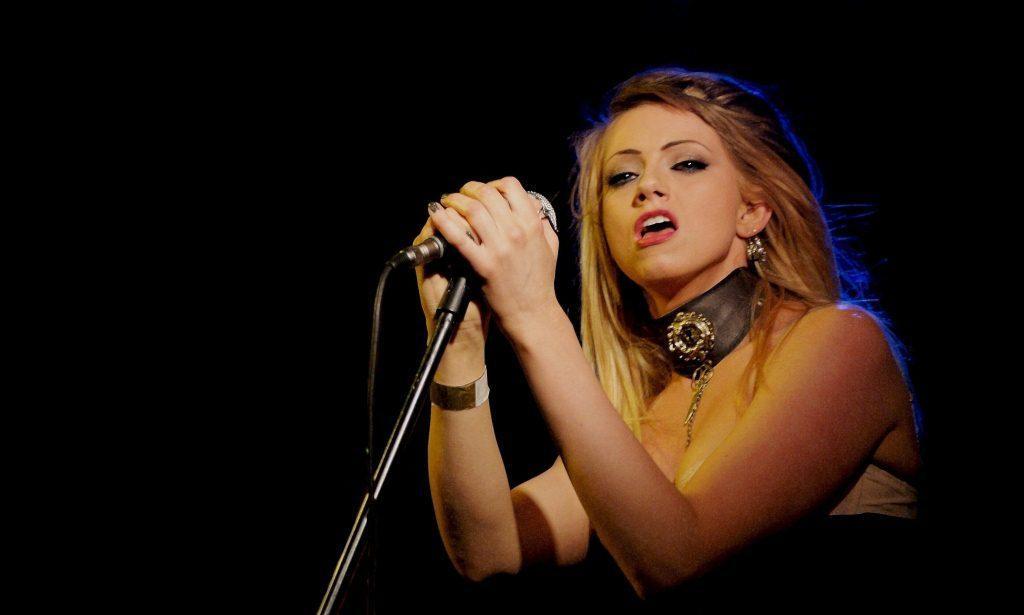Can you describe this image briefly? In this picture there is a woman she is singing a song, she held microphone with both of her hands and she is looking somewhere else and she is wearing necklace and she is wearing a band to her right hand. 